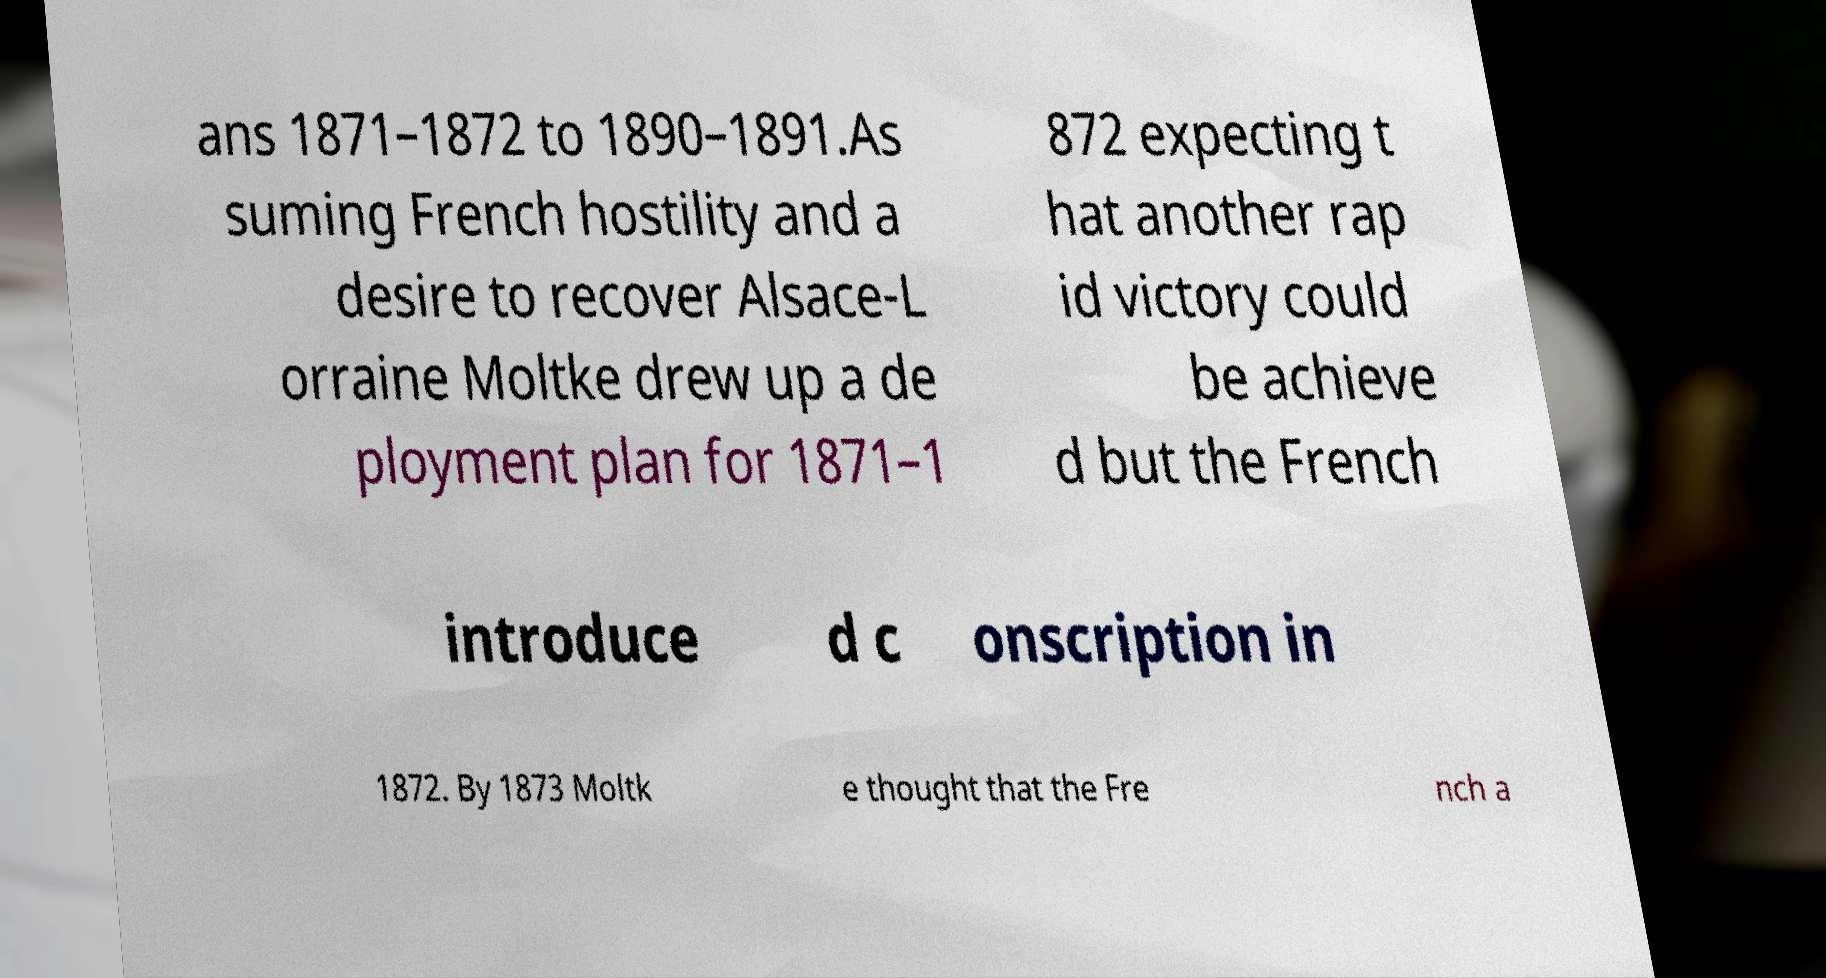For documentation purposes, I need the text within this image transcribed. Could you provide that? ans 1871–1872 to 1890–1891.As suming French hostility and a desire to recover Alsace-L orraine Moltke drew up a de ployment plan for 1871–1 872 expecting t hat another rap id victory could be achieve d but the French introduce d c onscription in 1872. By 1873 Moltk e thought that the Fre nch a 